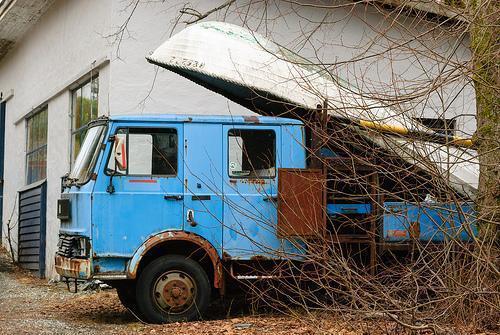How many trucks are in the photo?
Give a very brief answer. 1. 